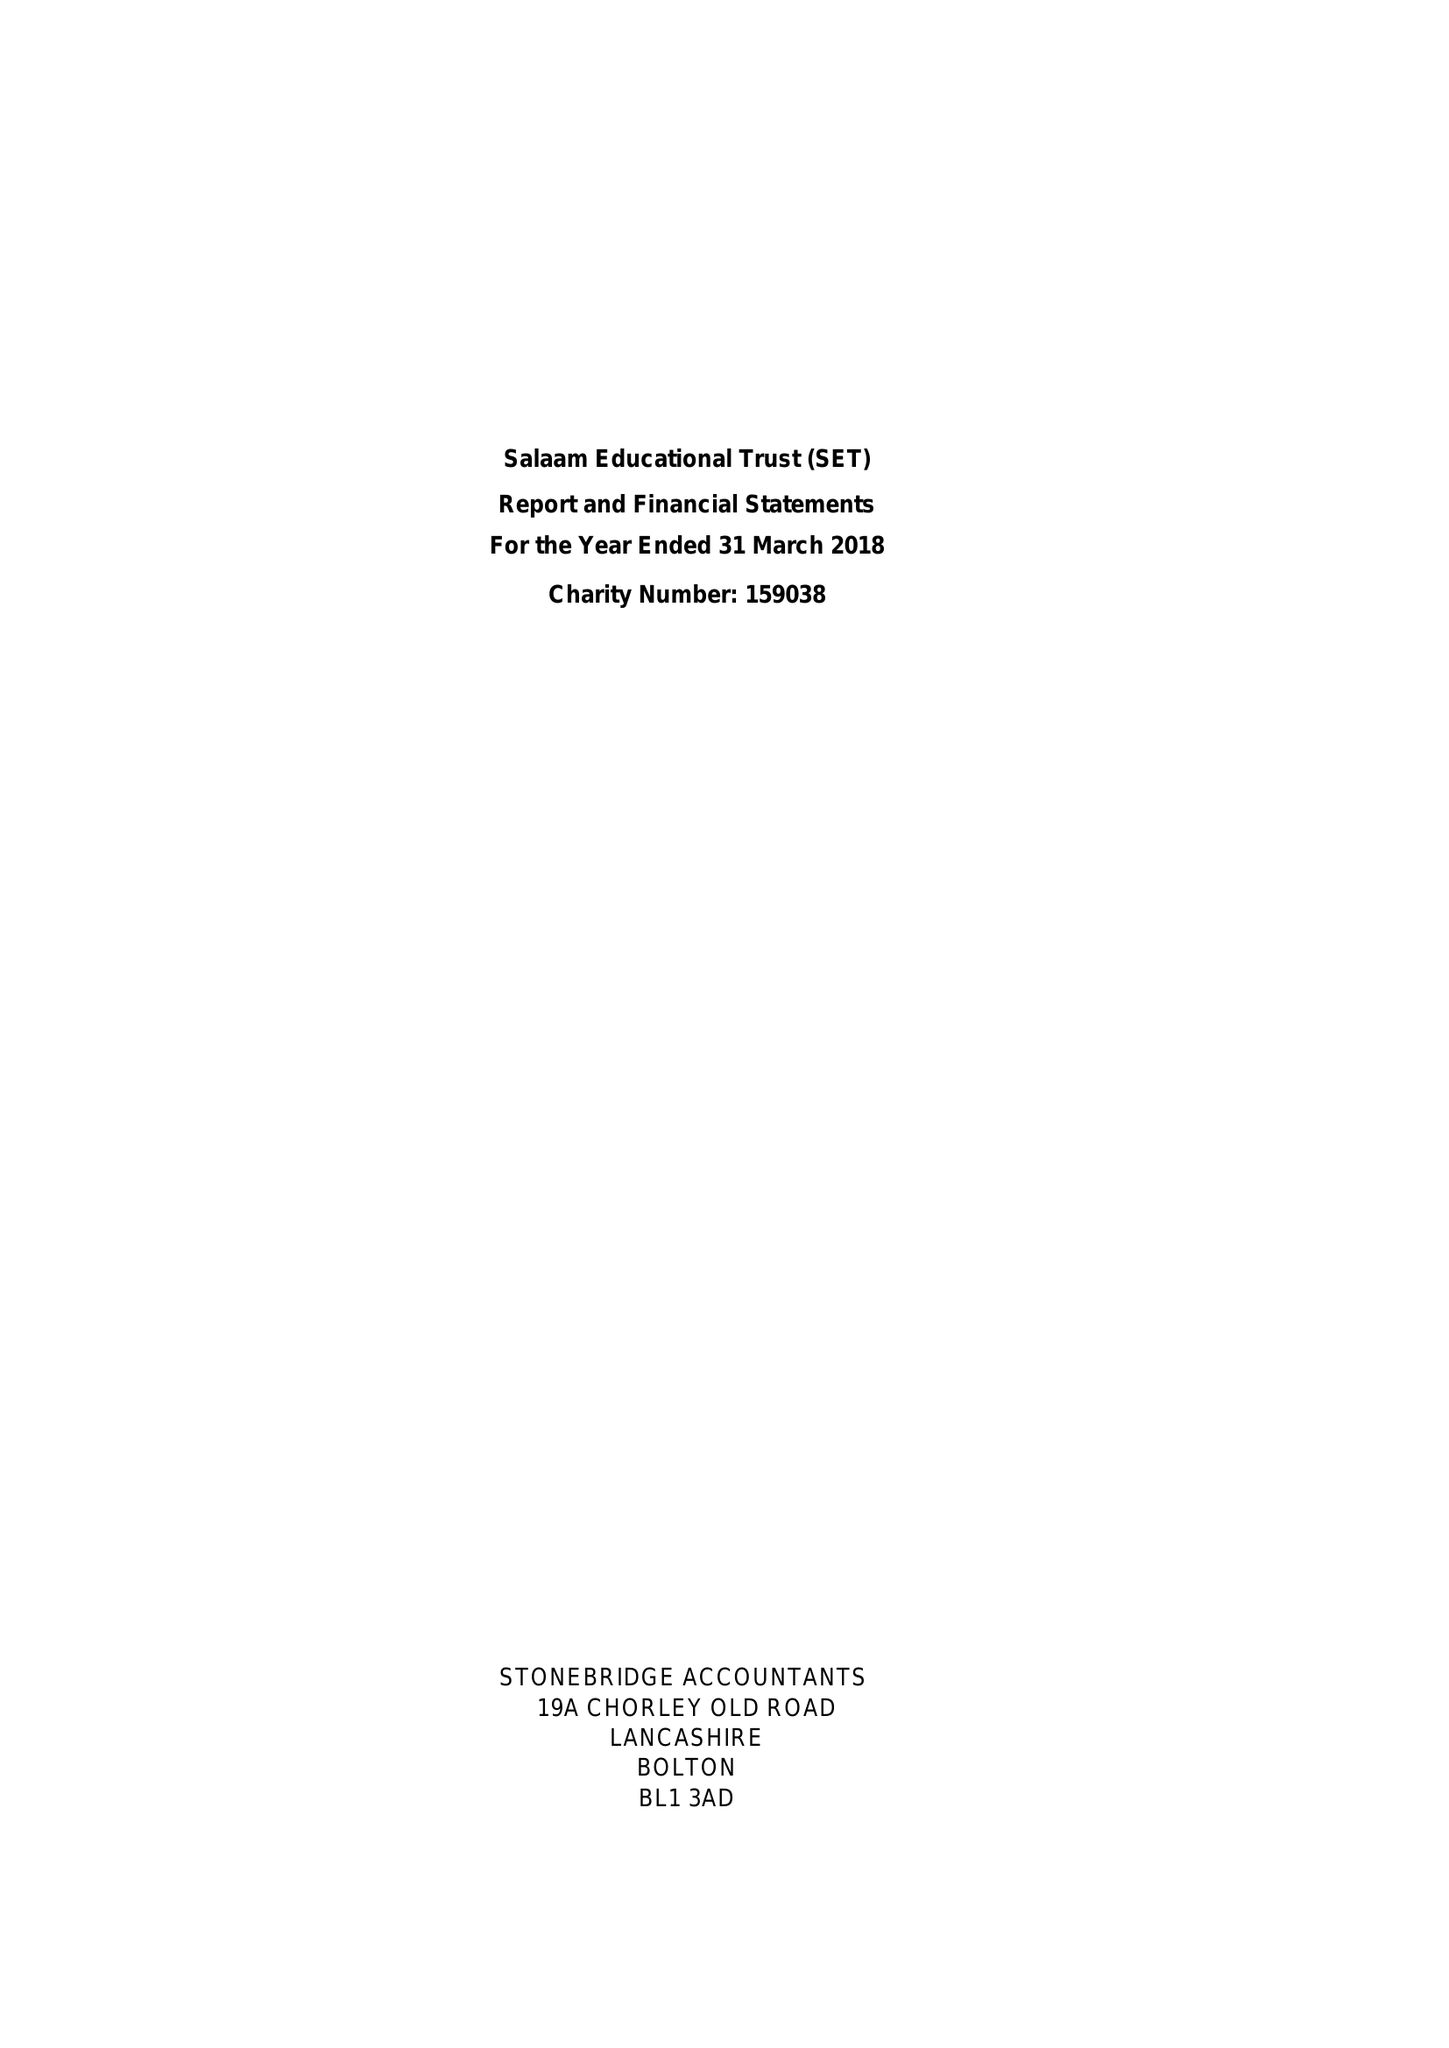What is the value for the address__post_town?
Answer the question using a single word or phrase. PRESTON 